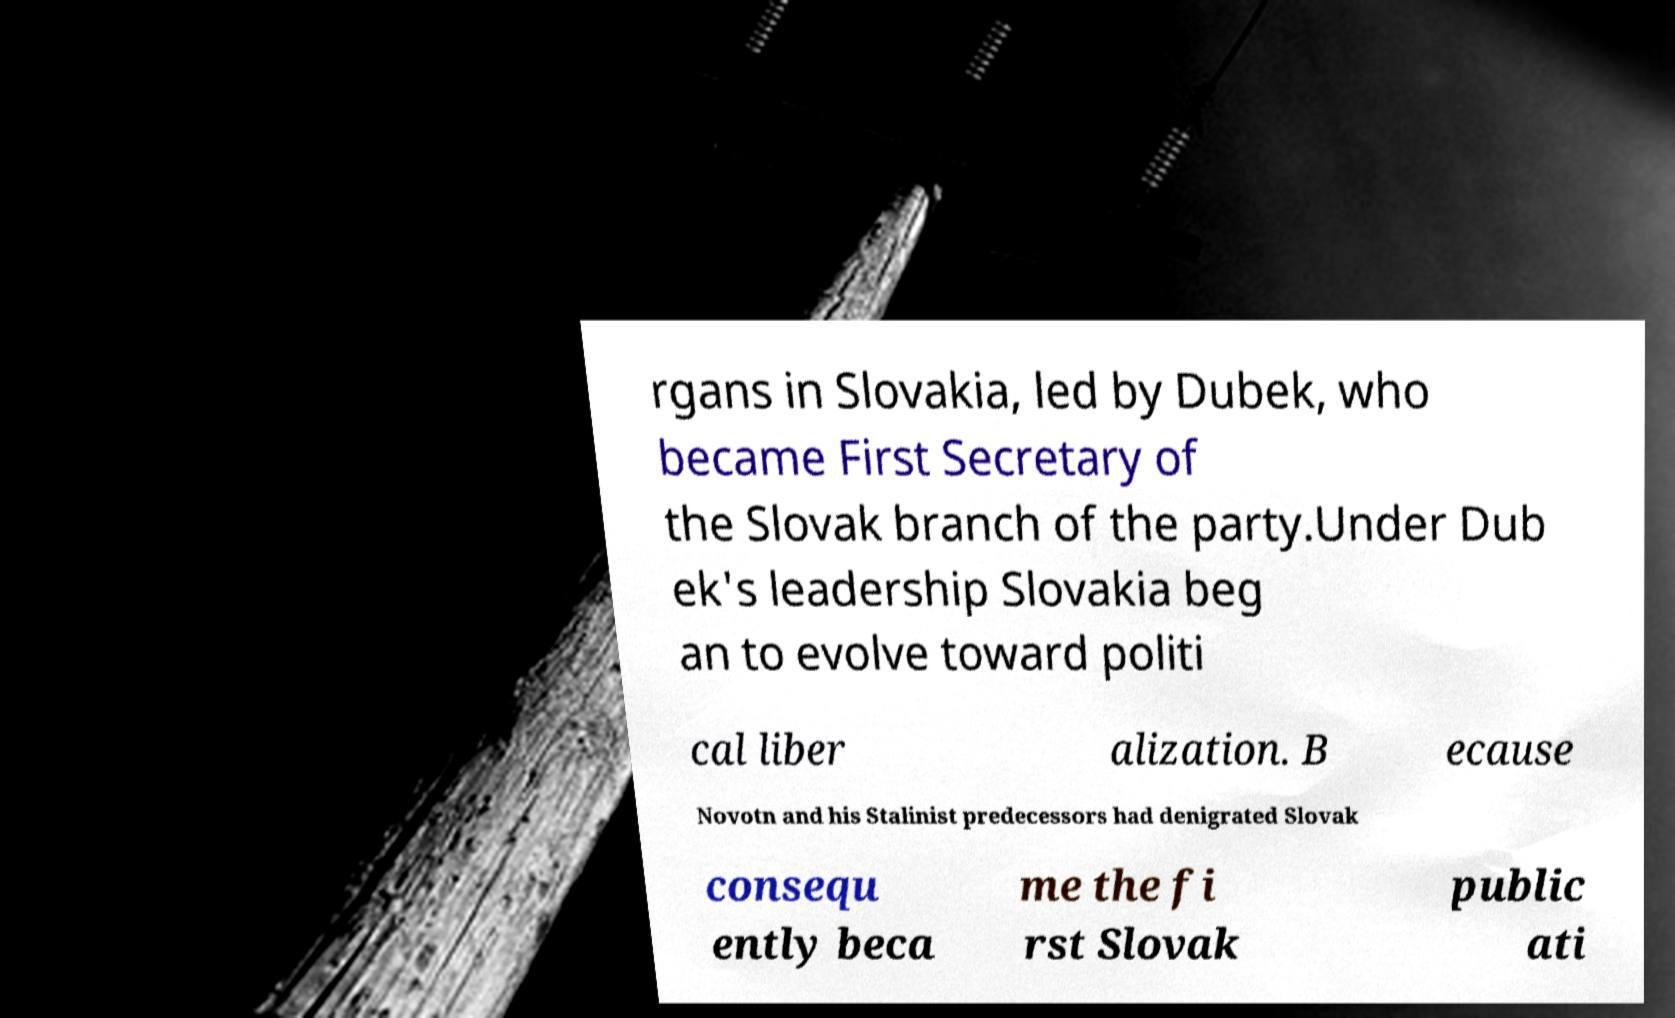What messages or text are displayed in this image? I need them in a readable, typed format. rgans in Slovakia, led by Dubek, who became First Secretary of the Slovak branch of the party.Under Dub ek's leadership Slovakia beg an to evolve toward politi cal liber alization. B ecause Novotn and his Stalinist predecessors had denigrated Slovak consequ ently beca me the fi rst Slovak public ati 